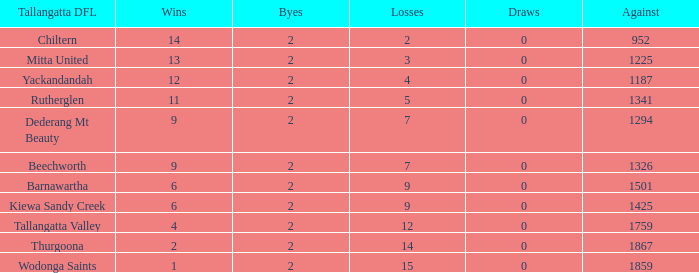What is the most byes with 11 wins and fewer than 1867 againsts? 2.0. 